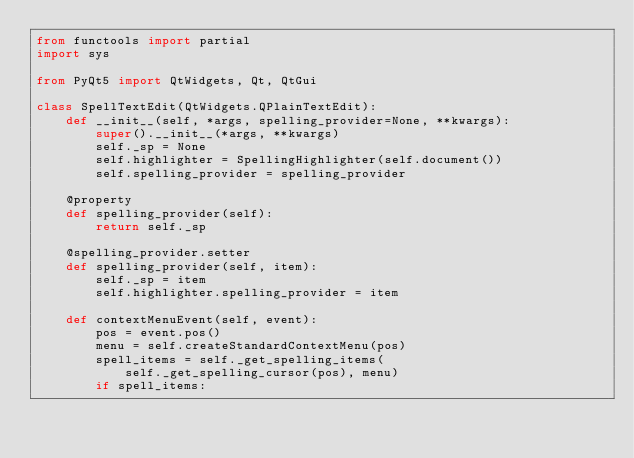<code> <loc_0><loc_0><loc_500><loc_500><_Python_>from functools import partial
import sys

from PyQt5 import QtWidgets, Qt, QtGui

class SpellTextEdit(QtWidgets.QPlainTextEdit):
    def __init__(self, *args, spelling_provider=None, **kwargs):
        super().__init__(*args, **kwargs)
        self._sp = None
        self.highlighter = SpellingHighlighter(self.document())
        self.spelling_provider = spelling_provider

    @property
    def spelling_provider(self):
        return self._sp

    @spelling_provider.setter
    def spelling_provider(self, item):
        self._sp = item
        self.highlighter.spelling_provider = item

    def contextMenuEvent(self, event):
        pos = event.pos()
        menu = self.createStandardContextMenu(pos)
        spell_items = self._get_spelling_items(
            self._get_spelling_cursor(pos), menu)
        if spell_items:</code> 